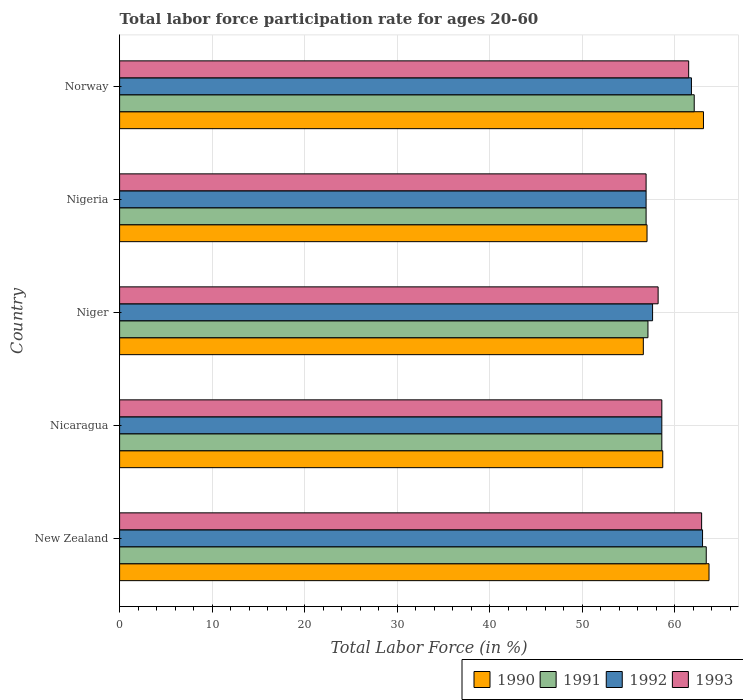How many different coloured bars are there?
Offer a terse response. 4. Are the number of bars per tick equal to the number of legend labels?
Offer a very short reply. Yes. How many bars are there on the 1st tick from the top?
Give a very brief answer. 4. How many bars are there on the 3rd tick from the bottom?
Offer a terse response. 4. What is the label of the 2nd group of bars from the top?
Your answer should be compact. Nigeria. What is the labor force participation rate in 1992 in Nigeria?
Offer a very short reply. 56.9. Across all countries, what is the minimum labor force participation rate in 1991?
Offer a terse response. 56.9. In which country was the labor force participation rate in 1991 maximum?
Ensure brevity in your answer.  New Zealand. In which country was the labor force participation rate in 1993 minimum?
Give a very brief answer. Nigeria. What is the total labor force participation rate in 1993 in the graph?
Make the answer very short. 298.1. What is the difference between the labor force participation rate in 1993 in New Zealand and that in Nicaragua?
Keep it short and to the point. 4.3. What is the average labor force participation rate in 1990 per country?
Your answer should be very brief. 59.82. What is the difference between the labor force participation rate in 1992 and labor force participation rate in 1991 in Nigeria?
Offer a terse response. 0. What is the ratio of the labor force participation rate in 1992 in Nicaragua to that in Niger?
Your response must be concise. 1.02. What is the difference between the highest and the second highest labor force participation rate in 1992?
Make the answer very short. 1.2. What is the difference between the highest and the lowest labor force participation rate in 1992?
Your answer should be compact. 6.1. What does the 1st bar from the top in Norway represents?
Offer a terse response. 1993. How many bars are there?
Provide a succinct answer. 20. How many countries are there in the graph?
Provide a short and direct response. 5. What is the difference between two consecutive major ticks on the X-axis?
Provide a succinct answer. 10. Are the values on the major ticks of X-axis written in scientific E-notation?
Make the answer very short. No. Does the graph contain grids?
Keep it short and to the point. Yes. Where does the legend appear in the graph?
Make the answer very short. Bottom right. What is the title of the graph?
Make the answer very short. Total labor force participation rate for ages 20-60. Does "2006" appear as one of the legend labels in the graph?
Make the answer very short. No. What is the label or title of the X-axis?
Ensure brevity in your answer.  Total Labor Force (in %). What is the label or title of the Y-axis?
Your response must be concise. Country. What is the Total Labor Force (in %) of 1990 in New Zealand?
Keep it short and to the point. 63.7. What is the Total Labor Force (in %) of 1991 in New Zealand?
Make the answer very short. 63.4. What is the Total Labor Force (in %) in 1993 in New Zealand?
Make the answer very short. 62.9. What is the Total Labor Force (in %) in 1990 in Nicaragua?
Offer a terse response. 58.7. What is the Total Labor Force (in %) of 1991 in Nicaragua?
Keep it short and to the point. 58.6. What is the Total Labor Force (in %) of 1992 in Nicaragua?
Your answer should be very brief. 58.6. What is the Total Labor Force (in %) of 1993 in Nicaragua?
Offer a very short reply. 58.6. What is the Total Labor Force (in %) in 1990 in Niger?
Offer a terse response. 56.6. What is the Total Labor Force (in %) of 1991 in Niger?
Offer a very short reply. 57.1. What is the Total Labor Force (in %) of 1992 in Niger?
Make the answer very short. 57.6. What is the Total Labor Force (in %) in 1993 in Niger?
Your answer should be compact. 58.2. What is the Total Labor Force (in %) of 1990 in Nigeria?
Offer a terse response. 57. What is the Total Labor Force (in %) in 1991 in Nigeria?
Give a very brief answer. 56.9. What is the Total Labor Force (in %) of 1992 in Nigeria?
Your answer should be very brief. 56.9. What is the Total Labor Force (in %) of 1993 in Nigeria?
Your answer should be very brief. 56.9. What is the Total Labor Force (in %) in 1990 in Norway?
Keep it short and to the point. 63.1. What is the Total Labor Force (in %) of 1991 in Norway?
Give a very brief answer. 62.1. What is the Total Labor Force (in %) of 1992 in Norway?
Your answer should be compact. 61.8. What is the Total Labor Force (in %) in 1993 in Norway?
Offer a very short reply. 61.5. Across all countries, what is the maximum Total Labor Force (in %) in 1990?
Provide a succinct answer. 63.7. Across all countries, what is the maximum Total Labor Force (in %) of 1991?
Your response must be concise. 63.4. Across all countries, what is the maximum Total Labor Force (in %) in 1992?
Give a very brief answer. 63. Across all countries, what is the maximum Total Labor Force (in %) in 1993?
Your answer should be very brief. 62.9. Across all countries, what is the minimum Total Labor Force (in %) in 1990?
Give a very brief answer. 56.6. Across all countries, what is the minimum Total Labor Force (in %) of 1991?
Make the answer very short. 56.9. Across all countries, what is the minimum Total Labor Force (in %) of 1992?
Provide a short and direct response. 56.9. Across all countries, what is the minimum Total Labor Force (in %) in 1993?
Offer a very short reply. 56.9. What is the total Total Labor Force (in %) of 1990 in the graph?
Make the answer very short. 299.1. What is the total Total Labor Force (in %) in 1991 in the graph?
Keep it short and to the point. 298.1. What is the total Total Labor Force (in %) in 1992 in the graph?
Offer a terse response. 297.9. What is the total Total Labor Force (in %) of 1993 in the graph?
Provide a short and direct response. 298.1. What is the difference between the Total Labor Force (in %) in 1990 in New Zealand and that in Nicaragua?
Offer a terse response. 5. What is the difference between the Total Labor Force (in %) in 1992 in New Zealand and that in Nicaragua?
Offer a very short reply. 4.4. What is the difference between the Total Labor Force (in %) in 1990 in New Zealand and that in Niger?
Keep it short and to the point. 7.1. What is the difference between the Total Labor Force (in %) in 1992 in New Zealand and that in Niger?
Offer a very short reply. 5.4. What is the difference between the Total Labor Force (in %) of 1993 in New Zealand and that in Nigeria?
Keep it short and to the point. 6. What is the difference between the Total Labor Force (in %) of 1992 in New Zealand and that in Norway?
Give a very brief answer. 1.2. What is the difference between the Total Labor Force (in %) of 1993 in New Zealand and that in Norway?
Make the answer very short. 1.4. What is the difference between the Total Labor Force (in %) of 1991 in Nicaragua and that in Nigeria?
Provide a succinct answer. 1.7. What is the difference between the Total Labor Force (in %) of 1993 in Nicaragua and that in Nigeria?
Make the answer very short. 1.7. What is the difference between the Total Labor Force (in %) of 1990 in Nicaragua and that in Norway?
Offer a terse response. -4.4. What is the difference between the Total Labor Force (in %) in 1992 in Nicaragua and that in Norway?
Give a very brief answer. -3.2. What is the difference between the Total Labor Force (in %) in 1993 in Nicaragua and that in Norway?
Provide a short and direct response. -2.9. What is the difference between the Total Labor Force (in %) in 1991 in Niger and that in Nigeria?
Give a very brief answer. 0.2. What is the difference between the Total Labor Force (in %) in 1992 in Niger and that in Nigeria?
Ensure brevity in your answer.  0.7. What is the difference between the Total Labor Force (in %) of 1991 in Niger and that in Norway?
Keep it short and to the point. -5. What is the difference between the Total Labor Force (in %) in 1993 in Niger and that in Norway?
Give a very brief answer. -3.3. What is the difference between the Total Labor Force (in %) of 1991 in Nigeria and that in Norway?
Give a very brief answer. -5.2. What is the difference between the Total Labor Force (in %) of 1993 in Nigeria and that in Norway?
Ensure brevity in your answer.  -4.6. What is the difference between the Total Labor Force (in %) of 1990 in New Zealand and the Total Labor Force (in %) of 1991 in Nicaragua?
Offer a very short reply. 5.1. What is the difference between the Total Labor Force (in %) in 1990 in New Zealand and the Total Labor Force (in %) in 1993 in Nicaragua?
Ensure brevity in your answer.  5.1. What is the difference between the Total Labor Force (in %) of 1991 in New Zealand and the Total Labor Force (in %) of 1992 in Nicaragua?
Ensure brevity in your answer.  4.8. What is the difference between the Total Labor Force (in %) of 1990 in New Zealand and the Total Labor Force (in %) of 1991 in Niger?
Offer a very short reply. 6.6. What is the difference between the Total Labor Force (in %) of 1990 in New Zealand and the Total Labor Force (in %) of 1992 in Niger?
Provide a succinct answer. 6.1. What is the difference between the Total Labor Force (in %) of 1990 in New Zealand and the Total Labor Force (in %) of 1993 in Niger?
Ensure brevity in your answer.  5.5. What is the difference between the Total Labor Force (in %) of 1991 in New Zealand and the Total Labor Force (in %) of 1993 in Niger?
Make the answer very short. 5.2. What is the difference between the Total Labor Force (in %) of 1990 in New Zealand and the Total Labor Force (in %) of 1992 in Nigeria?
Make the answer very short. 6.8. What is the difference between the Total Labor Force (in %) of 1991 in New Zealand and the Total Labor Force (in %) of 1992 in Nigeria?
Offer a terse response. 6.5. What is the difference between the Total Labor Force (in %) in 1991 in New Zealand and the Total Labor Force (in %) in 1993 in Nigeria?
Ensure brevity in your answer.  6.5. What is the difference between the Total Labor Force (in %) in 1992 in New Zealand and the Total Labor Force (in %) in 1993 in Nigeria?
Offer a very short reply. 6.1. What is the difference between the Total Labor Force (in %) in 1990 in New Zealand and the Total Labor Force (in %) in 1992 in Norway?
Offer a terse response. 1.9. What is the difference between the Total Labor Force (in %) in 1990 in New Zealand and the Total Labor Force (in %) in 1993 in Norway?
Provide a short and direct response. 2.2. What is the difference between the Total Labor Force (in %) in 1991 in New Zealand and the Total Labor Force (in %) in 1993 in Norway?
Provide a succinct answer. 1.9. What is the difference between the Total Labor Force (in %) of 1992 in New Zealand and the Total Labor Force (in %) of 1993 in Norway?
Ensure brevity in your answer.  1.5. What is the difference between the Total Labor Force (in %) in 1990 in Nicaragua and the Total Labor Force (in %) in 1992 in Niger?
Offer a very short reply. 1.1. What is the difference between the Total Labor Force (in %) of 1992 in Nicaragua and the Total Labor Force (in %) of 1993 in Niger?
Provide a succinct answer. 0.4. What is the difference between the Total Labor Force (in %) of 1990 in Nicaragua and the Total Labor Force (in %) of 1991 in Nigeria?
Your response must be concise. 1.8. What is the difference between the Total Labor Force (in %) in 1990 in Nicaragua and the Total Labor Force (in %) in 1992 in Nigeria?
Keep it short and to the point. 1.8. What is the difference between the Total Labor Force (in %) of 1990 in Nicaragua and the Total Labor Force (in %) of 1993 in Nigeria?
Ensure brevity in your answer.  1.8. What is the difference between the Total Labor Force (in %) in 1992 in Nicaragua and the Total Labor Force (in %) in 1993 in Nigeria?
Your answer should be compact. 1.7. What is the difference between the Total Labor Force (in %) in 1990 in Nicaragua and the Total Labor Force (in %) in 1991 in Norway?
Your answer should be compact. -3.4. What is the difference between the Total Labor Force (in %) in 1990 in Niger and the Total Labor Force (in %) in 1993 in Nigeria?
Provide a short and direct response. -0.3. What is the difference between the Total Labor Force (in %) in 1992 in Niger and the Total Labor Force (in %) in 1993 in Nigeria?
Provide a succinct answer. 0.7. What is the difference between the Total Labor Force (in %) in 1990 in Niger and the Total Labor Force (in %) in 1991 in Norway?
Your answer should be compact. -5.5. What is the difference between the Total Labor Force (in %) of 1990 in Nigeria and the Total Labor Force (in %) of 1991 in Norway?
Keep it short and to the point. -5.1. What is the difference between the Total Labor Force (in %) in 1990 in Nigeria and the Total Labor Force (in %) in 1992 in Norway?
Ensure brevity in your answer.  -4.8. What is the difference between the Total Labor Force (in %) in 1991 in Nigeria and the Total Labor Force (in %) in 1992 in Norway?
Provide a short and direct response. -4.9. What is the difference between the Total Labor Force (in %) in 1991 in Nigeria and the Total Labor Force (in %) in 1993 in Norway?
Your answer should be very brief. -4.6. What is the average Total Labor Force (in %) of 1990 per country?
Ensure brevity in your answer.  59.82. What is the average Total Labor Force (in %) of 1991 per country?
Offer a very short reply. 59.62. What is the average Total Labor Force (in %) of 1992 per country?
Provide a succinct answer. 59.58. What is the average Total Labor Force (in %) in 1993 per country?
Offer a terse response. 59.62. What is the difference between the Total Labor Force (in %) of 1990 and Total Labor Force (in %) of 1991 in New Zealand?
Your answer should be very brief. 0.3. What is the difference between the Total Labor Force (in %) of 1990 and Total Labor Force (in %) of 1992 in New Zealand?
Keep it short and to the point. 0.7. What is the difference between the Total Labor Force (in %) of 1990 and Total Labor Force (in %) of 1993 in New Zealand?
Your answer should be very brief. 0.8. What is the difference between the Total Labor Force (in %) in 1991 and Total Labor Force (in %) in 1993 in New Zealand?
Offer a very short reply. 0.5. What is the difference between the Total Labor Force (in %) in 1992 and Total Labor Force (in %) in 1993 in New Zealand?
Give a very brief answer. 0.1. What is the difference between the Total Labor Force (in %) in 1990 and Total Labor Force (in %) in 1991 in Nicaragua?
Provide a short and direct response. 0.1. What is the difference between the Total Labor Force (in %) of 1991 and Total Labor Force (in %) of 1992 in Nicaragua?
Provide a short and direct response. 0. What is the difference between the Total Labor Force (in %) of 1992 and Total Labor Force (in %) of 1993 in Nicaragua?
Provide a short and direct response. 0. What is the difference between the Total Labor Force (in %) of 1990 and Total Labor Force (in %) of 1991 in Niger?
Offer a terse response. -0.5. What is the difference between the Total Labor Force (in %) of 1990 and Total Labor Force (in %) of 1992 in Niger?
Provide a short and direct response. -1. What is the difference between the Total Labor Force (in %) in 1990 and Total Labor Force (in %) in 1993 in Niger?
Your answer should be very brief. -1.6. What is the difference between the Total Labor Force (in %) in 1991 and Total Labor Force (in %) in 1993 in Niger?
Provide a short and direct response. -1.1. What is the difference between the Total Labor Force (in %) of 1992 and Total Labor Force (in %) of 1993 in Niger?
Offer a terse response. -0.6. What is the difference between the Total Labor Force (in %) in 1990 and Total Labor Force (in %) in 1991 in Nigeria?
Keep it short and to the point. 0.1. What is the difference between the Total Labor Force (in %) of 1990 and Total Labor Force (in %) of 1992 in Nigeria?
Ensure brevity in your answer.  0.1. What is the difference between the Total Labor Force (in %) in 1992 and Total Labor Force (in %) in 1993 in Nigeria?
Make the answer very short. 0. What is the difference between the Total Labor Force (in %) in 1990 and Total Labor Force (in %) in 1991 in Norway?
Offer a terse response. 1. What is the difference between the Total Labor Force (in %) of 1991 and Total Labor Force (in %) of 1992 in Norway?
Ensure brevity in your answer.  0.3. What is the ratio of the Total Labor Force (in %) of 1990 in New Zealand to that in Nicaragua?
Offer a terse response. 1.09. What is the ratio of the Total Labor Force (in %) in 1991 in New Zealand to that in Nicaragua?
Provide a short and direct response. 1.08. What is the ratio of the Total Labor Force (in %) of 1992 in New Zealand to that in Nicaragua?
Keep it short and to the point. 1.08. What is the ratio of the Total Labor Force (in %) of 1993 in New Zealand to that in Nicaragua?
Offer a very short reply. 1.07. What is the ratio of the Total Labor Force (in %) in 1990 in New Zealand to that in Niger?
Provide a succinct answer. 1.13. What is the ratio of the Total Labor Force (in %) in 1991 in New Zealand to that in Niger?
Offer a very short reply. 1.11. What is the ratio of the Total Labor Force (in %) of 1992 in New Zealand to that in Niger?
Offer a terse response. 1.09. What is the ratio of the Total Labor Force (in %) of 1993 in New Zealand to that in Niger?
Your answer should be very brief. 1.08. What is the ratio of the Total Labor Force (in %) of 1990 in New Zealand to that in Nigeria?
Keep it short and to the point. 1.12. What is the ratio of the Total Labor Force (in %) in 1991 in New Zealand to that in Nigeria?
Make the answer very short. 1.11. What is the ratio of the Total Labor Force (in %) of 1992 in New Zealand to that in Nigeria?
Make the answer very short. 1.11. What is the ratio of the Total Labor Force (in %) in 1993 in New Zealand to that in Nigeria?
Keep it short and to the point. 1.11. What is the ratio of the Total Labor Force (in %) in 1990 in New Zealand to that in Norway?
Your response must be concise. 1.01. What is the ratio of the Total Labor Force (in %) of 1991 in New Zealand to that in Norway?
Give a very brief answer. 1.02. What is the ratio of the Total Labor Force (in %) in 1992 in New Zealand to that in Norway?
Offer a terse response. 1.02. What is the ratio of the Total Labor Force (in %) in 1993 in New Zealand to that in Norway?
Your answer should be very brief. 1.02. What is the ratio of the Total Labor Force (in %) of 1990 in Nicaragua to that in Niger?
Give a very brief answer. 1.04. What is the ratio of the Total Labor Force (in %) in 1991 in Nicaragua to that in Niger?
Give a very brief answer. 1.03. What is the ratio of the Total Labor Force (in %) in 1992 in Nicaragua to that in Niger?
Your answer should be compact. 1.02. What is the ratio of the Total Labor Force (in %) in 1993 in Nicaragua to that in Niger?
Offer a very short reply. 1.01. What is the ratio of the Total Labor Force (in %) in 1990 in Nicaragua to that in Nigeria?
Give a very brief answer. 1.03. What is the ratio of the Total Labor Force (in %) in 1991 in Nicaragua to that in Nigeria?
Offer a very short reply. 1.03. What is the ratio of the Total Labor Force (in %) of 1992 in Nicaragua to that in Nigeria?
Give a very brief answer. 1.03. What is the ratio of the Total Labor Force (in %) in 1993 in Nicaragua to that in Nigeria?
Give a very brief answer. 1.03. What is the ratio of the Total Labor Force (in %) in 1990 in Nicaragua to that in Norway?
Give a very brief answer. 0.93. What is the ratio of the Total Labor Force (in %) of 1991 in Nicaragua to that in Norway?
Make the answer very short. 0.94. What is the ratio of the Total Labor Force (in %) in 1992 in Nicaragua to that in Norway?
Make the answer very short. 0.95. What is the ratio of the Total Labor Force (in %) of 1993 in Nicaragua to that in Norway?
Offer a terse response. 0.95. What is the ratio of the Total Labor Force (in %) in 1991 in Niger to that in Nigeria?
Give a very brief answer. 1. What is the ratio of the Total Labor Force (in %) in 1992 in Niger to that in Nigeria?
Provide a short and direct response. 1.01. What is the ratio of the Total Labor Force (in %) of 1993 in Niger to that in Nigeria?
Offer a terse response. 1.02. What is the ratio of the Total Labor Force (in %) in 1990 in Niger to that in Norway?
Provide a short and direct response. 0.9. What is the ratio of the Total Labor Force (in %) in 1991 in Niger to that in Norway?
Offer a very short reply. 0.92. What is the ratio of the Total Labor Force (in %) of 1992 in Niger to that in Norway?
Your response must be concise. 0.93. What is the ratio of the Total Labor Force (in %) in 1993 in Niger to that in Norway?
Give a very brief answer. 0.95. What is the ratio of the Total Labor Force (in %) in 1990 in Nigeria to that in Norway?
Make the answer very short. 0.9. What is the ratio of the Total Labor Force (in %) of 1991 in Nigeria to that in Norway?
Ensure brevity in your answer.  0.92. What is the ratio of the Total Labor Force (in %) in 1992 in Nigeria to that in Norway?
Provide a short and direct response. 0.92. What is the ratio of the Total Labor Force (in %) in 1993 in Nigeria to that in Norway?
Offer a terse response. 0.93. What is the difference between the highest and the second highest Total Labor Force (in %) in 1990?
Give a very brief answer. 0.6. What is the difference between the highest and the lowest Total Labor Force (in %) in 1991?
Offer a very short reply. 6.5. 